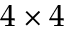Convert formula to latex. <formula><loc_0><loc_0><loc_500><loc_500>4 \times 4</formula> 